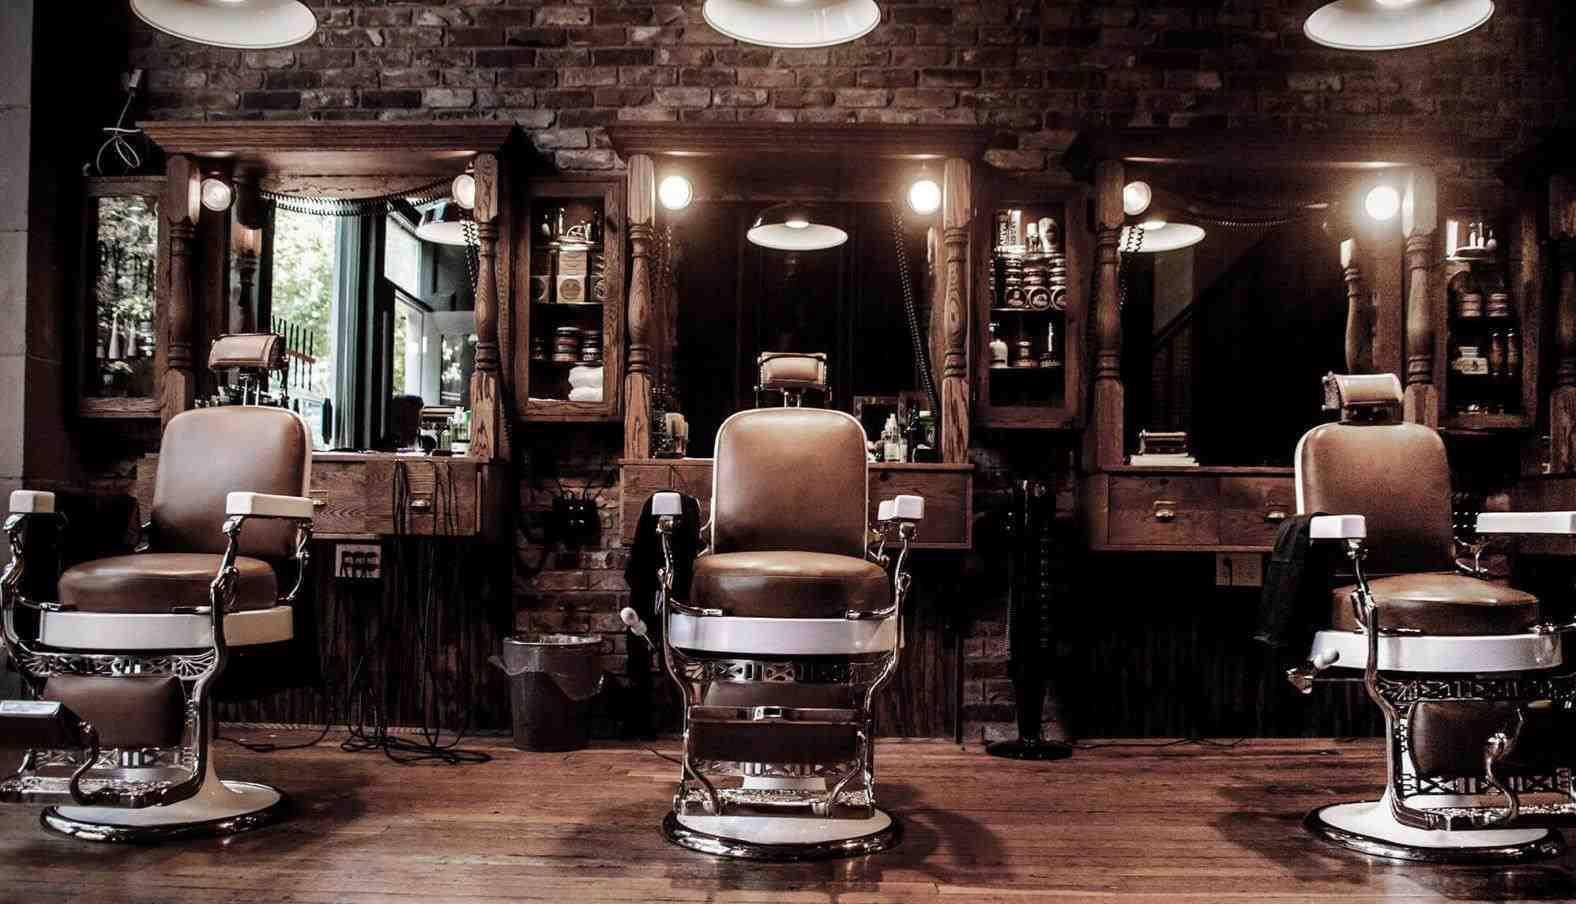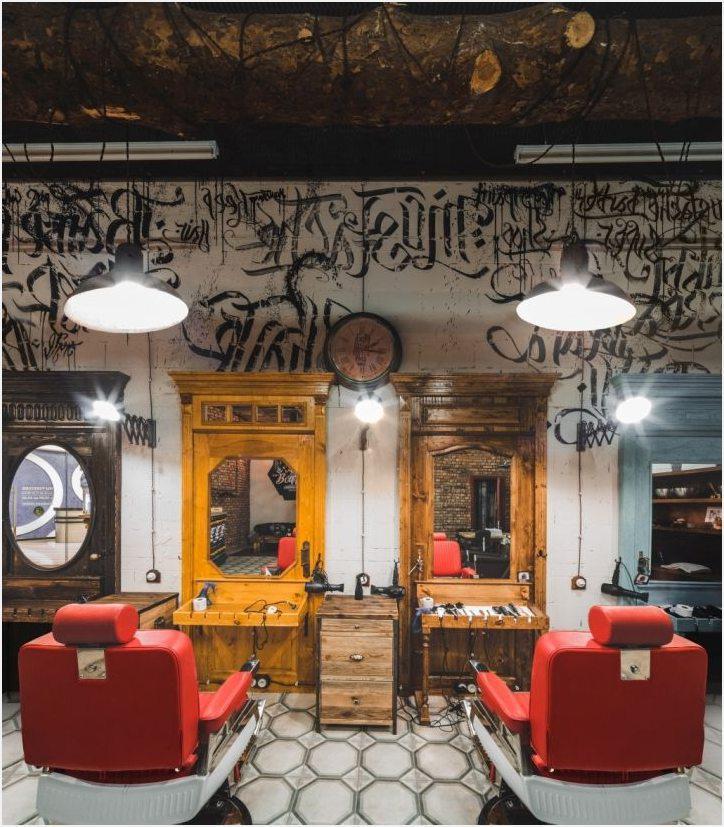The first image is the image on the left, the second image is the image on the right. For the images shown, is this caption "In the left image, a row of empty black barber chairs face leftward toward a countertop." true? Answer yes or no. No. The first image is the image on the left, the second image is the image on the right. For the images shown, is this caption "In at least one image there are at least two red empty barber chairs." true? Answer yes or no. Yes. 